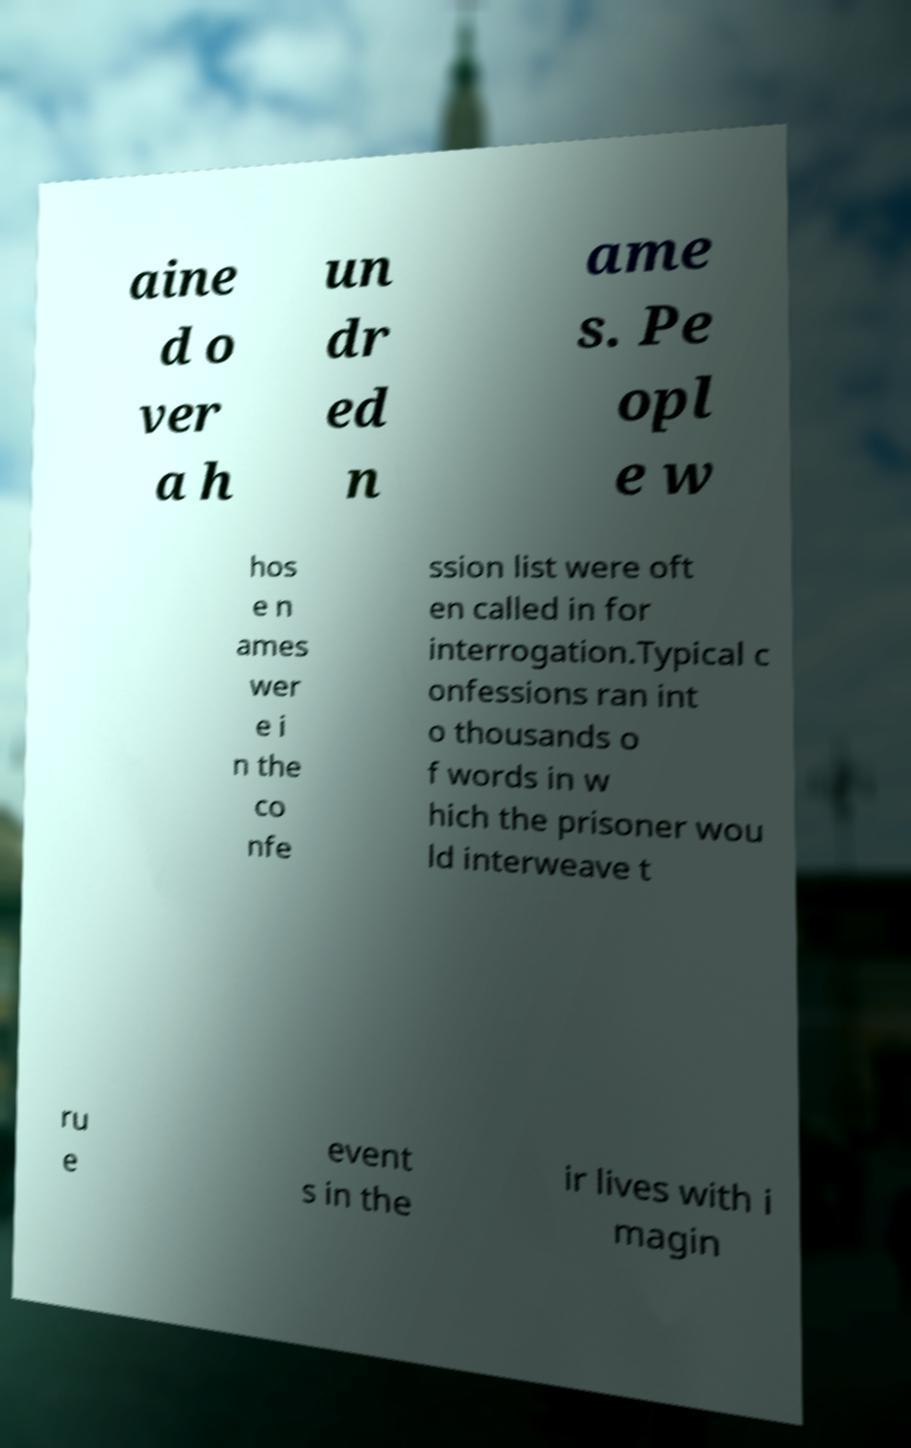I need the written content from this picture converted into text. Can you do that? aine d o ver a h un dr ed n ame s. Pe opl e w hos e n ames wer e i n the co nfe ssion list were oft en called in for interrogation.Typical c onfessions ran int o thousands o f words in w hich the prisoner wou ld interweave t ru e event s in the ir lives with i magin 